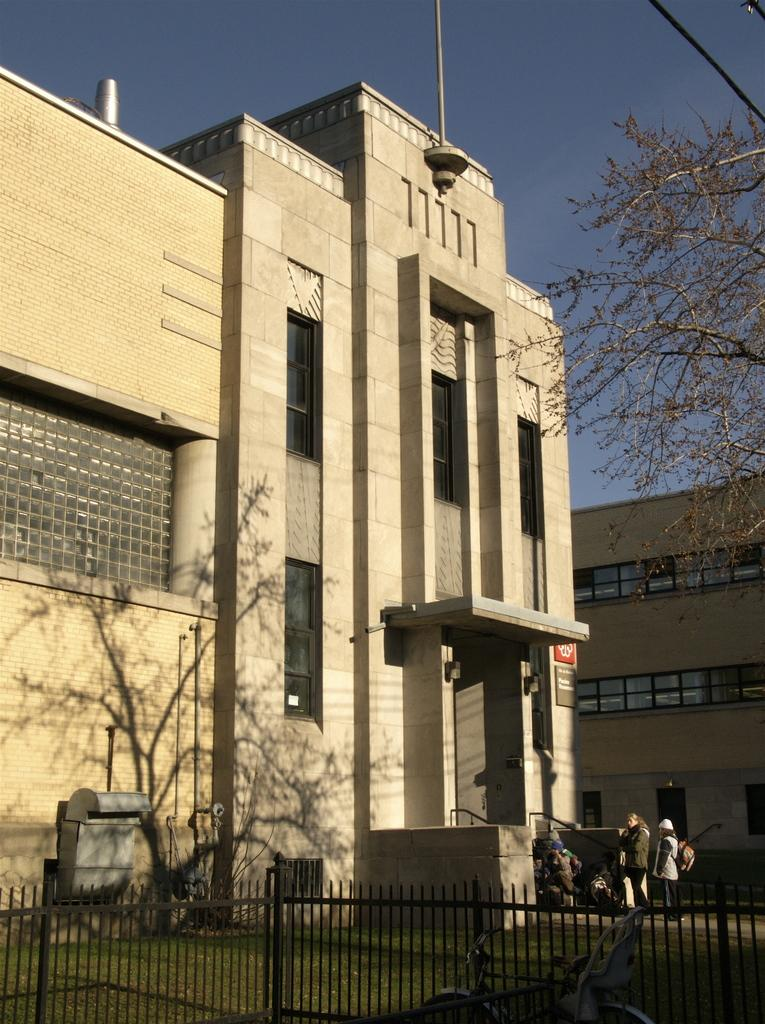What type of structures can be seen in the image? There are buildings in the image. What other elements are present in the image besides buildings? There are trees, people, a fence, boards, and poles in the image. Can you describe the attire of some people in the image? Some people are wearing coats and caps, and some are carrying bags. What is visible at the top of the image? The sky is visible at the top of the image. What time of day is it in the image, according to the hour? The provided facts do not mention a specific time of day or any clocks in the image, so it is impossible to determine the hour. Are there any police officers visible in the image? There is no mention of police officers in the provided facts, so it cannot be determined if they are present in the image. 